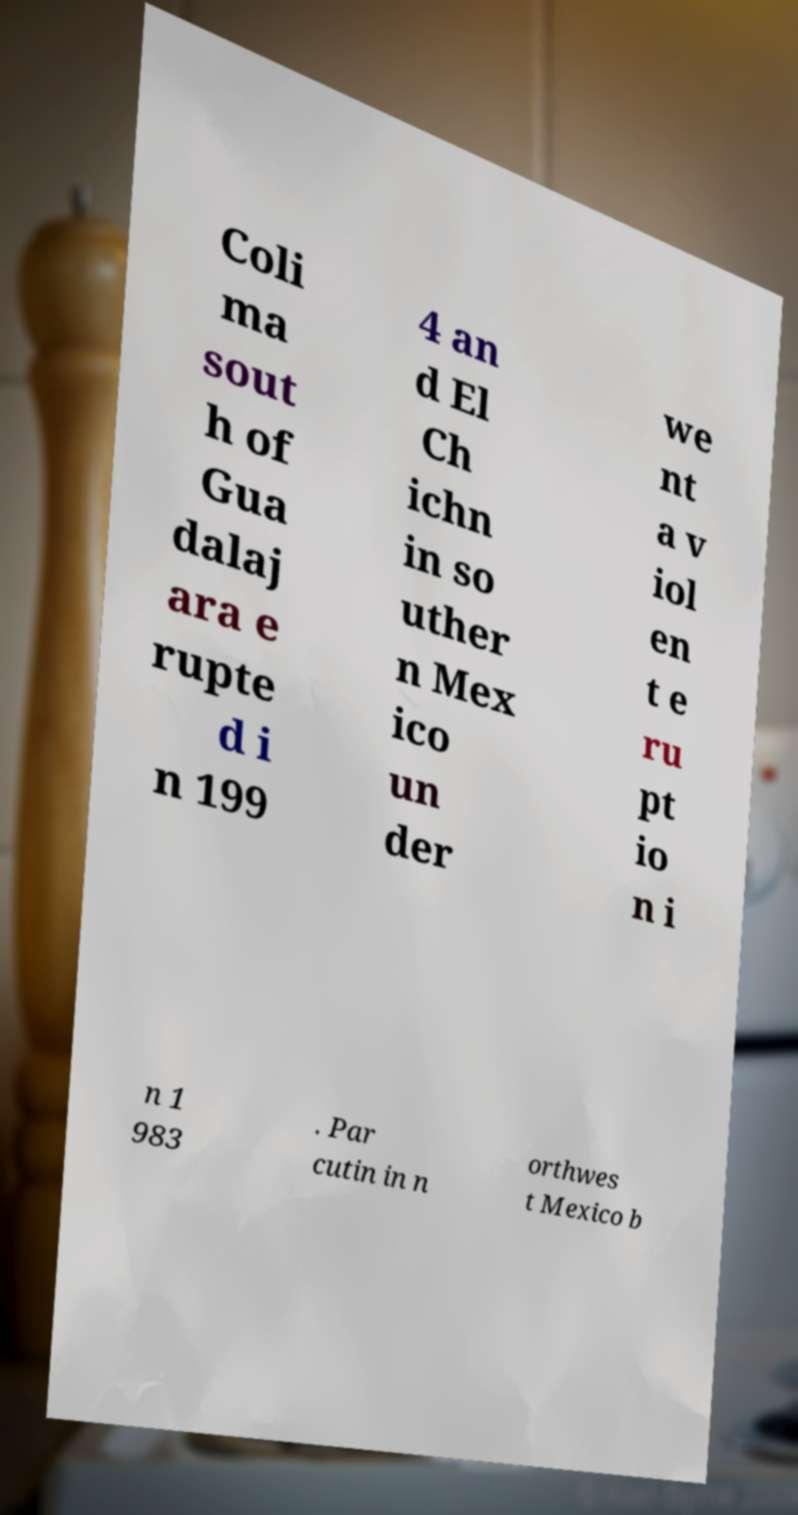Please read and relay the text visible in this image. What does it say? Coli ma sout h of Gua dalaj ara e rupte d i n 199 4 an d El Ch ichn in so uther n Mex ico un der we nt a v iol en t e ru pt io n i n 1 983 . Par cutin in n orthwes t Mexico b 